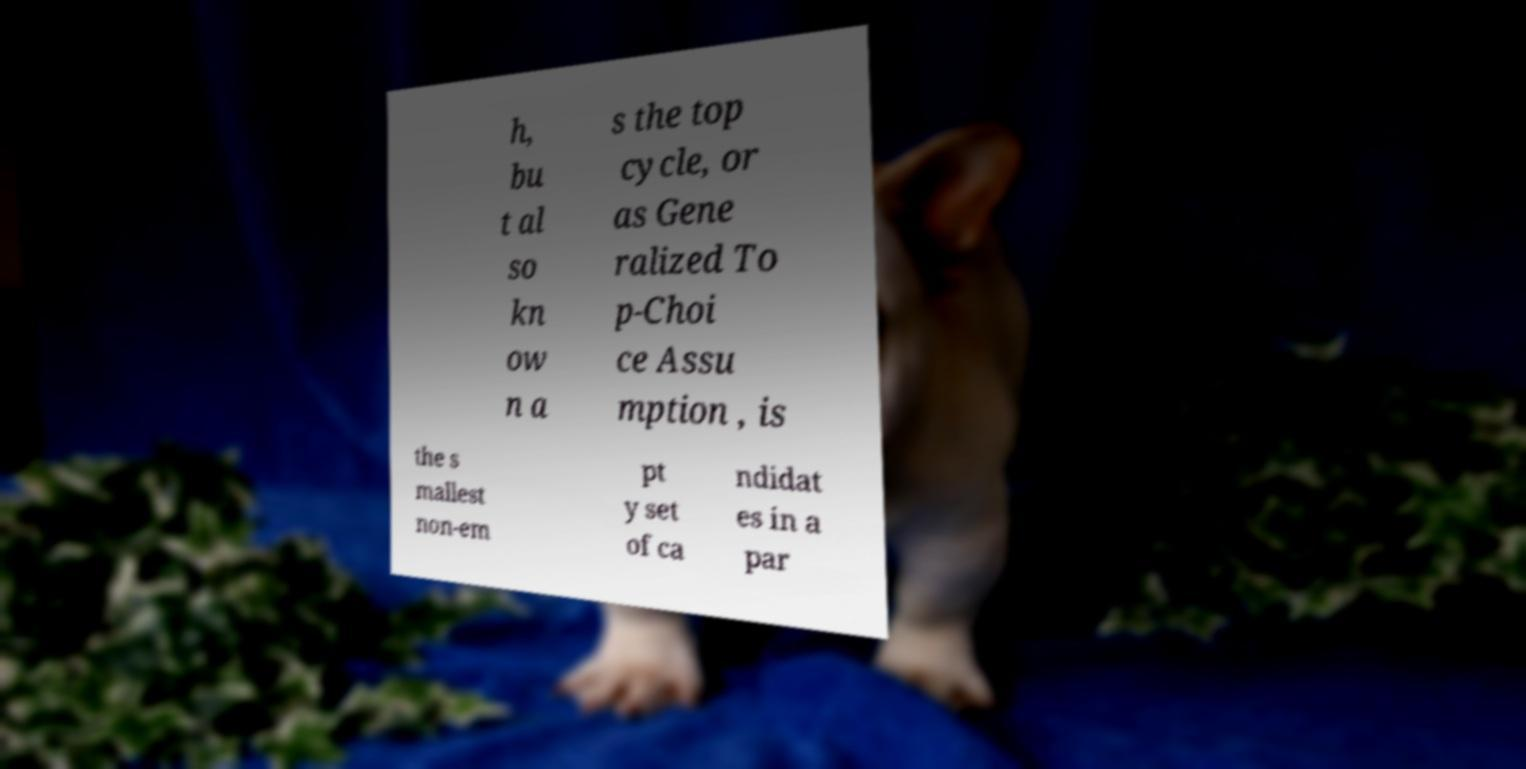Please read and relay the text visible in this image. What does it say? h, bu t al so kn ow n a s the top cycle, or as Gene ralized To p-Choi ce Assu mption , is the s mallest non-em pt y set of ca ndidat es in a par 